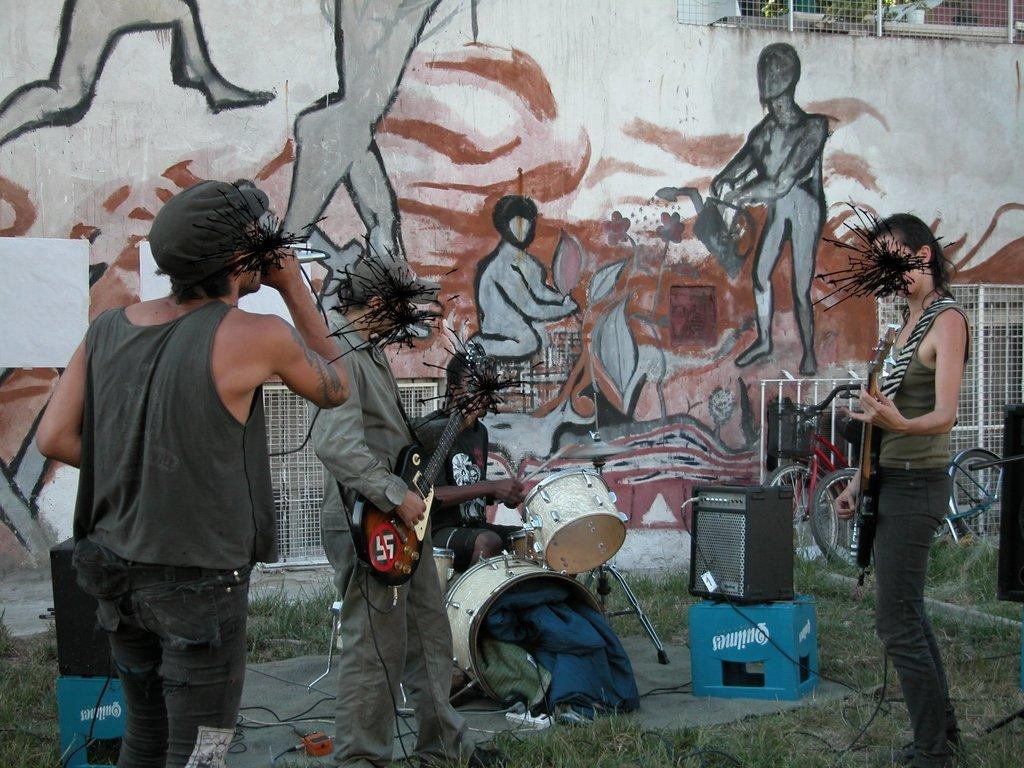How many people are in the image? There are four people in the image. What are the people doing in the image? The presence of musical instruments and speakers suggests that they might be performing or practicing music. What type of surface is visible in the image? Grass is visible in the image. What mode of transportation is present in the image? Bicycles are present in the image. What type of material is visible in the image? A mesh is visible in the image. What is on the wall in the background of the image? There is a painting on the wall in the background of the image. Where is the grandfather sitting in the image? There is no grandfather present in the image. What type of tent can be seen in the image? There is no tent present in the image. 